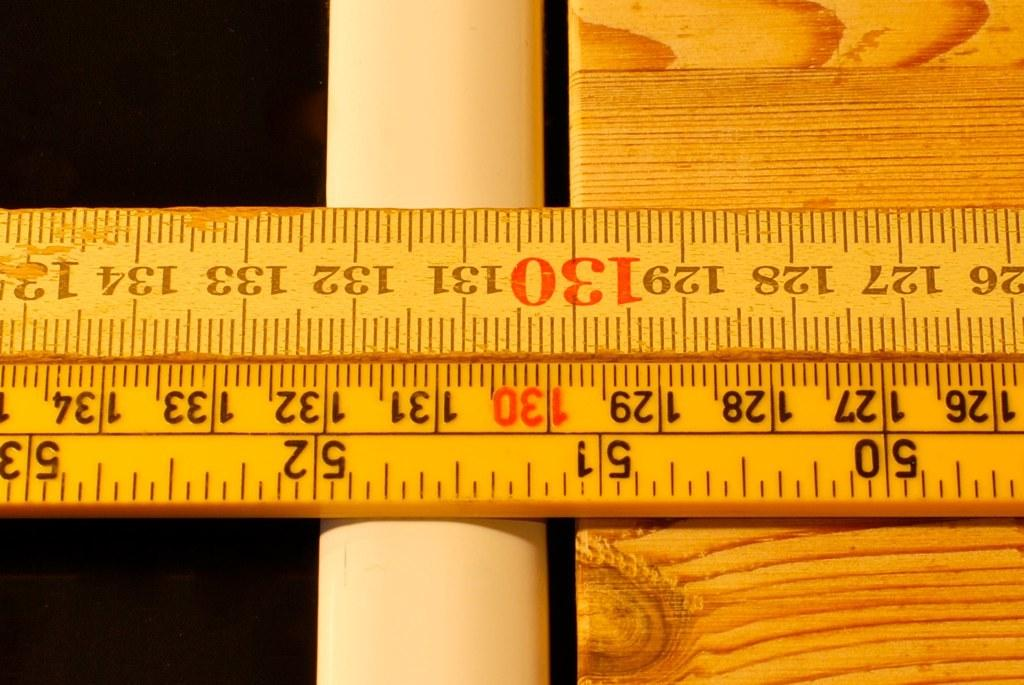Provide a one-sentence caption for the provided image. A wooden ruler has the number 130 in red on either side. 